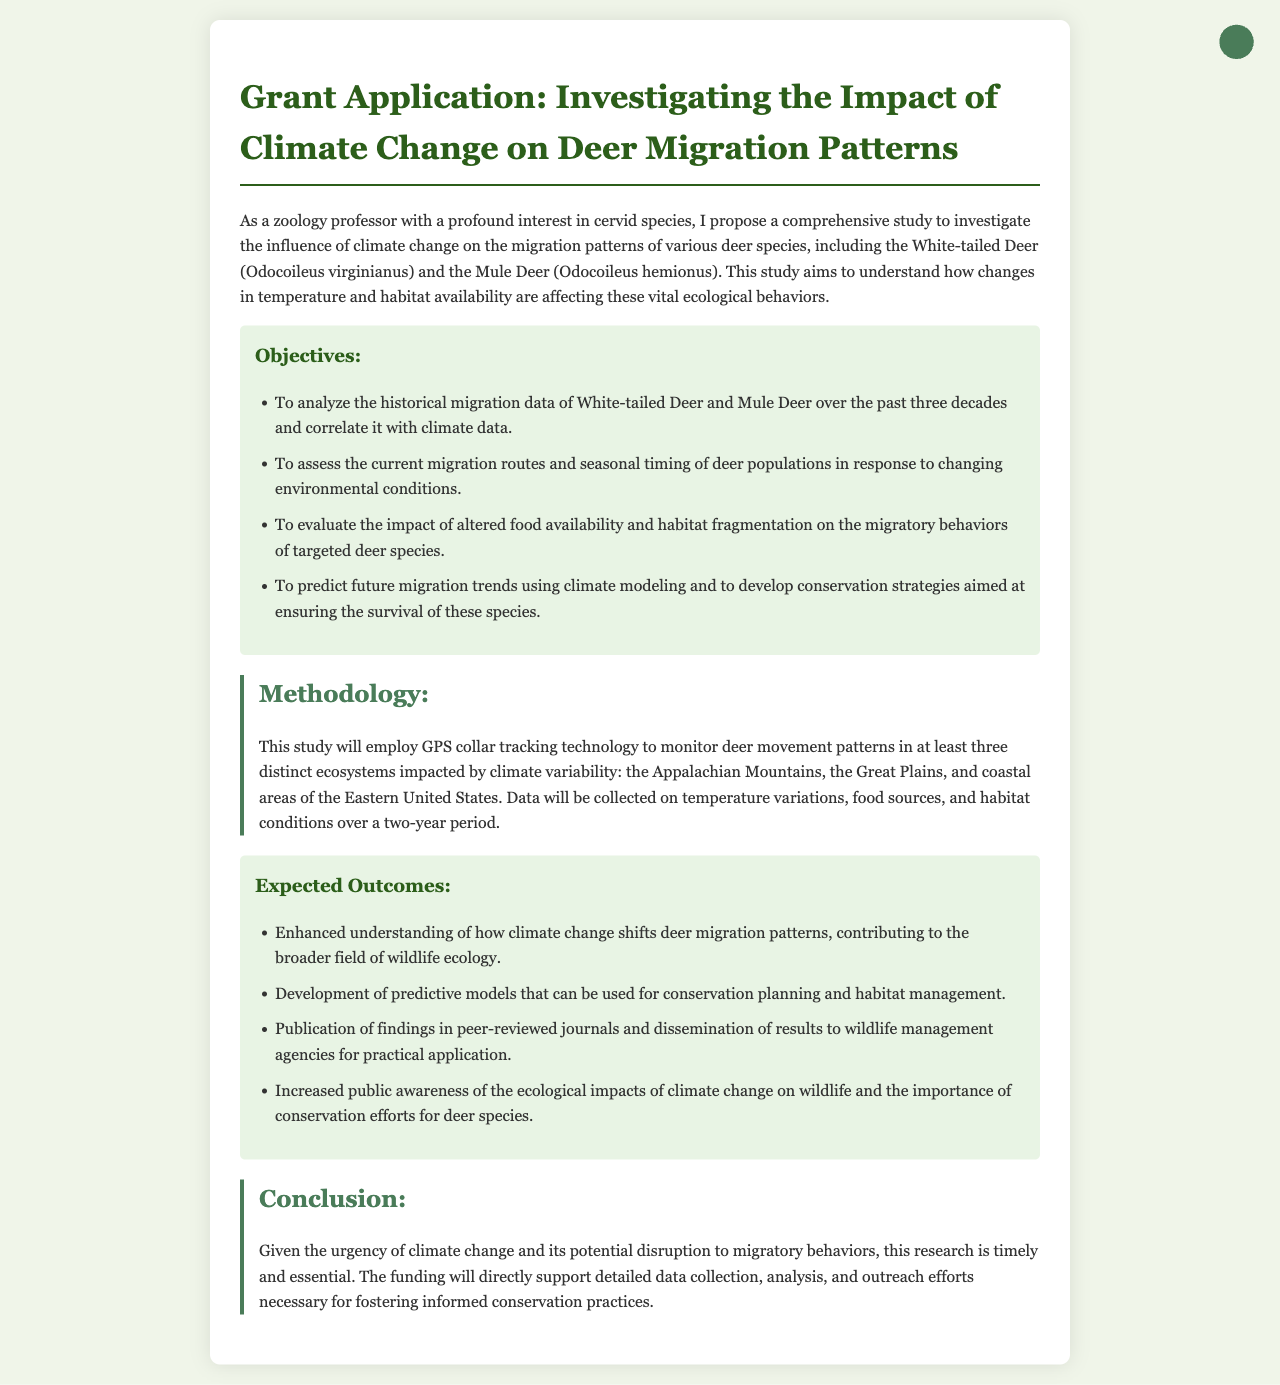What are the two deer species mentioned in the proposal? The document specifies the White-tailed Deer and the Mule Deer as the two species under study.
Answer: White-tailed Deer, Mule Deer How many decades of historical migration data will be analyzed? The proposal states that the historical migration data of deer over the past three decades will be analyzed for this study.
Answer: Three decades What is one of the objectives related to food availability for deer? The document mentions evaluating the impact of altered food availability on the migratory behaviors of targeted deer species as an objective.
Answer: Evaluate the impact of altered food availability How long will data be collected during the study? According to the methodology section, data will be collected over a two-year period during the study.
Answer: Two years What method will be used to monitor deer movement patterns? The proposal indicates that GPS collar tracking technology will be employed to monitor deer movement patterns.
Answer: GPS collar tracking technology What are the expected outcomes related to public knowledge? The document lists increasing public awareness of the ecological impacts of climate change on wildlife as one of the expected outcomes.
Answer: Increased public awareness Which ecosystems will be studied according to the methodology? The document mentions three distinct ecosystems: the Appalachian Mountains, the Great Plains, and coastal areas of the Eastern United States.
Answer: Appalachian Mountains, Great Plains, coastal areas of the Eastern United States What is the urgency of this research as stated in the conclusion? The conclusion emphasizes the urgency given the potential disruption to migratory behaviors due to climate change.
Answer: Urgent How many expected outcomes are listed in the document? The document enumerates four expected outcomes related to the research findings.
Answer: Four expected outcomes 